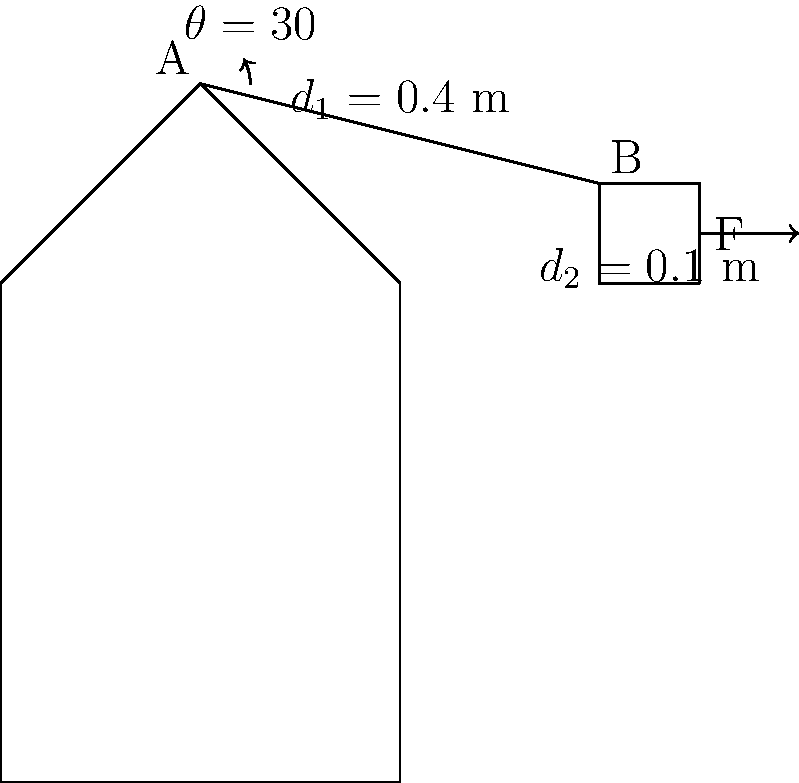In an emergency situation, a crisis communication expert needs to operate a wall-mounted communication device. The expert's arm is positioned as shown in the diagram, forming a 30° angle with the horizontal. If the expert applies a force of 50 N perpendicular to the device, what is the magnitude of the torque generated at the shoulder joint (point A) when operating the device? To calculate the torque generated at the shoulder joint, we need to follow these steps:

1. Identify the relevant information:
   - Force applied (F) = 50 N
   - Angle of the arm (θ) = 30°
   - Distance from shoulder to elbow (d₁) = 0.4 m
   - Distance from elbow to point of force application (d₂) = 0.1 m

2. Calculate the total moment arm:
   - The moment arm is the perpendicular distance from the axis of rotation (shoulder) to the line of action of the force.
   - Total moment arm = d₁ cos(θ) + d₂
   - Total moment arm = 0.4 cos(30°) + 0.1
   - Total moment arm = 0.4 * (√3/2) + 0.1 ≈ 0.446 m

3. Calculate the torque:
   - Torque (τ) = Force (F) * moment arm
   - τ = 50 N * 0.446 m
   - τ ≈ 22.3 N·m

Therefore, the magnitude of the torque generated at the shoulder joint is approximately 22.3 N·m.
Answer: 22.3 N·m 